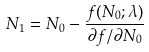Convert formula to latex. <formula><loc_0><loc_0><loc_500><loc_500>N _ { 1 } = N _ { 0 } - \frac { f ( N _ { 0 } ; \lambda ) } { \partial f / \partial N _ { 0 } }</formula> 